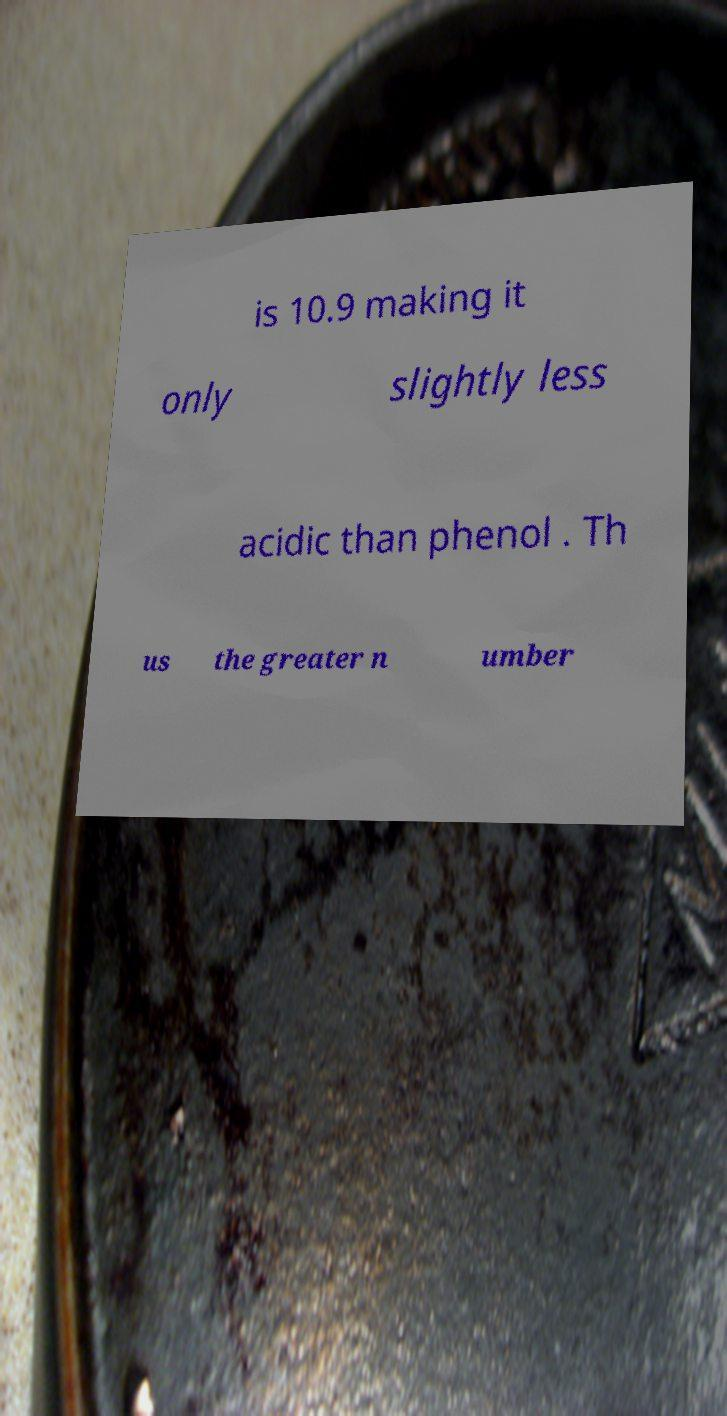I need the written content from this picture converted into text. Can you do that? is 10.9 making it only slightly less acidic than phenol . Th us the greater n umber 